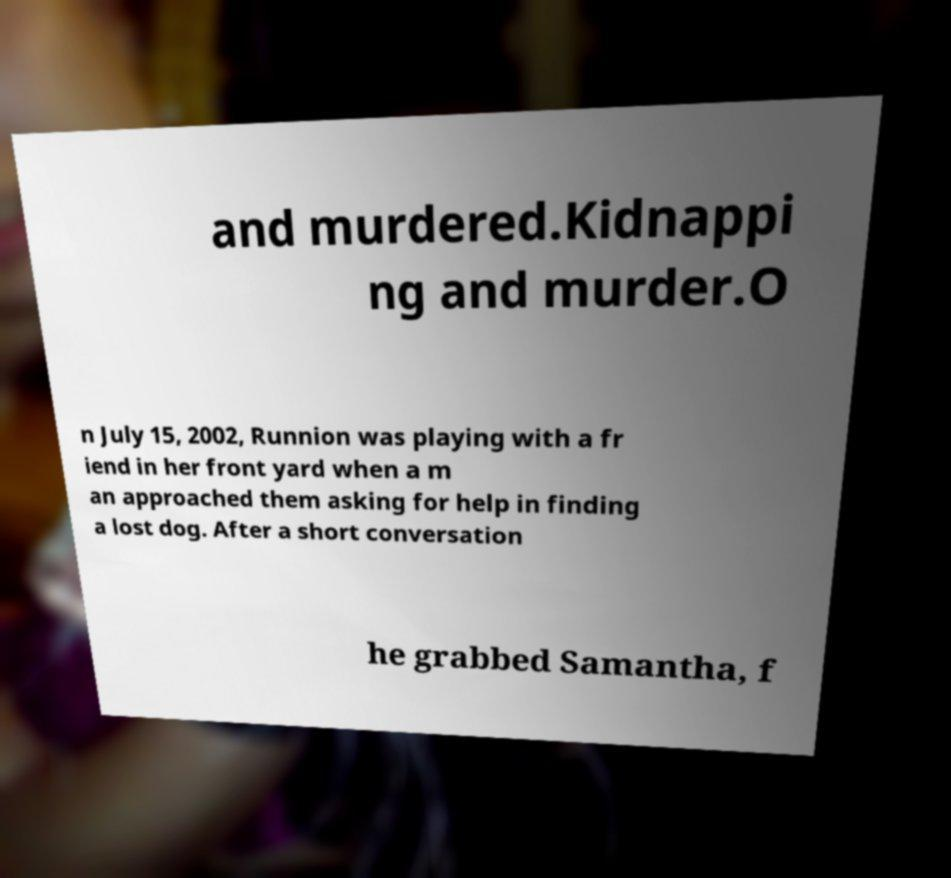Could you extract and type out the text from this image? and murdered.Kidnappi ng and murder.O n July 15, 2002, Runnion was playing with a fr iend in her front yard when a m an approached them asking for help in finding a lost dog. After a short conversation he grabbed Samantha, f 